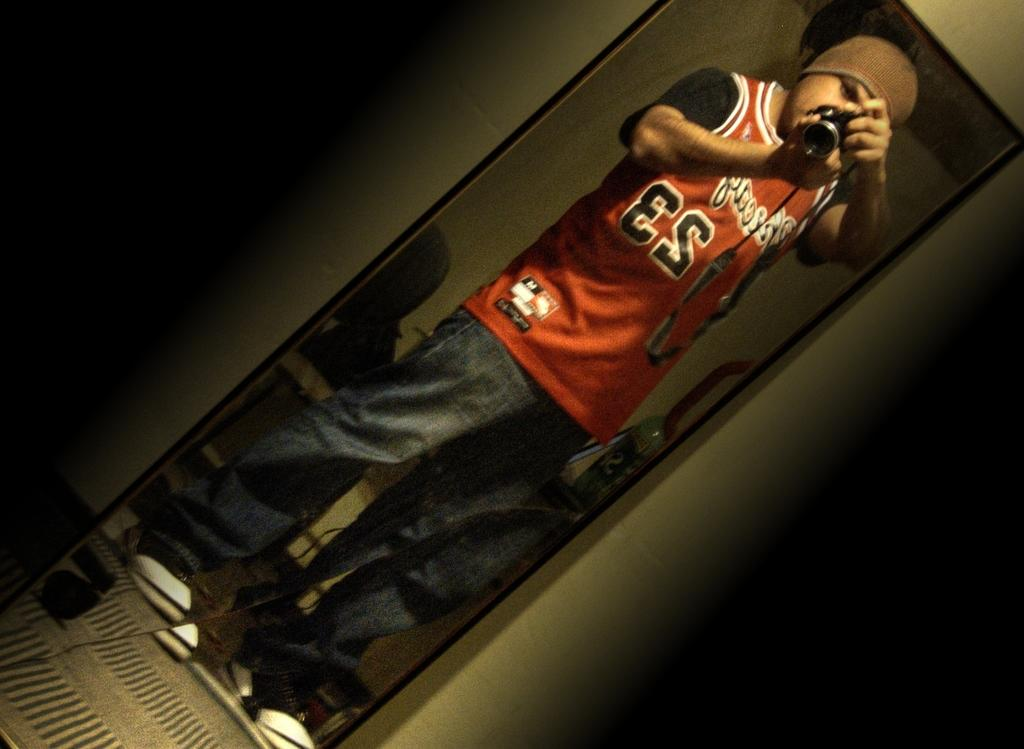<image>
Offer a succinct explanation of the picture presented. A man standing in front of a mirror taking a picture while wearing a red 23 jersey. 